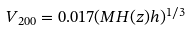<formula> <loc_0><loc_0><loc_500><loc_500>V _ { 2 0 0 } = 0 . 0 1 7 ( M H ( z ) h ) ^ { 1 / 3 }</formula> 